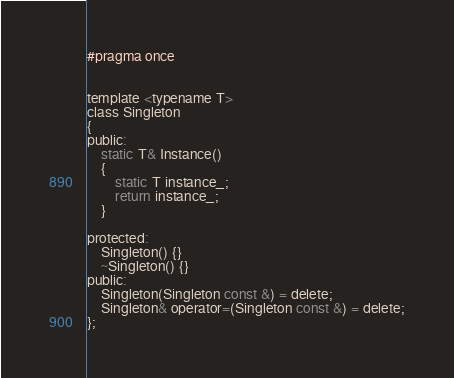Convert code to text. <code><loc_0><loc_0><loc_500><loc_500><_C_>#pragma once


template <typename T>
class Singleton
{
public:
    static T& Instance()
    {
        static T instance_;
        return instance_;
    }

protected:
    Singleton() {}
    ~Singleton() {}
public:
    Singleton(Singleton const &) = delete;
    Singleton& operator=(Singleton const &) = delete;
};</code> 